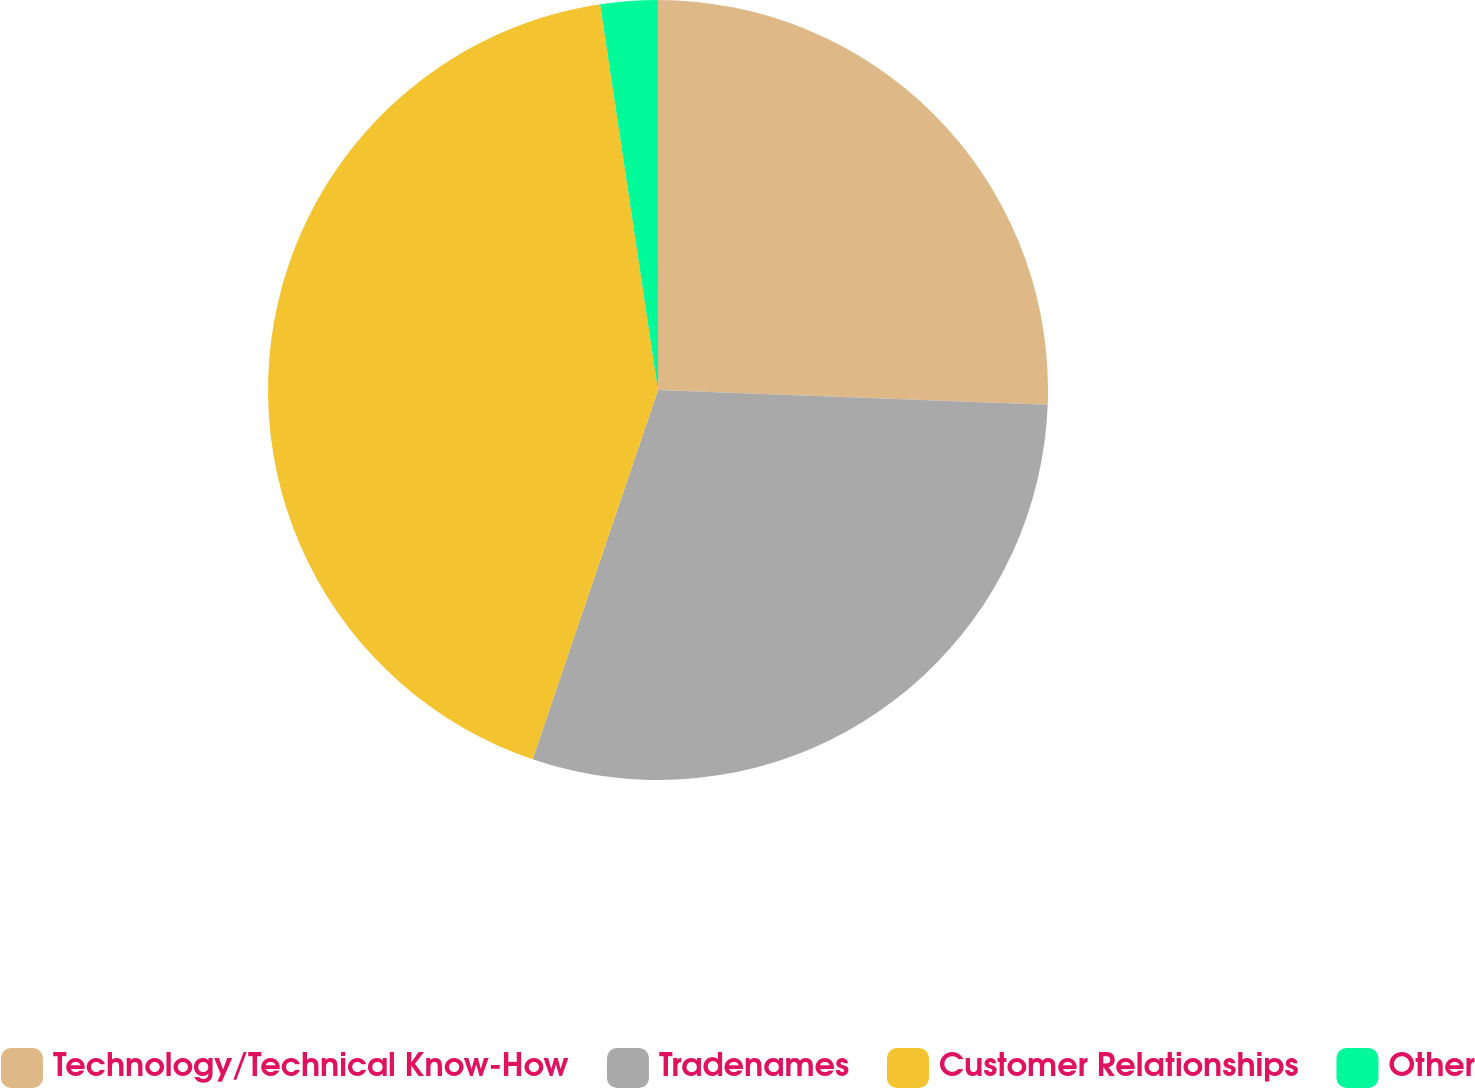Convert chart. <chart><loc_0><loc_0><loc_500><loc_500><pie_chart><fcel>Technology/Technical Know-How<fcel>Tradenames<fcel>Customer Relationships<fcel>Other<nl><fcel>25.6%<fcel>29.61%<fcel>42.42%<fcel>2.37%<nl></chart> 